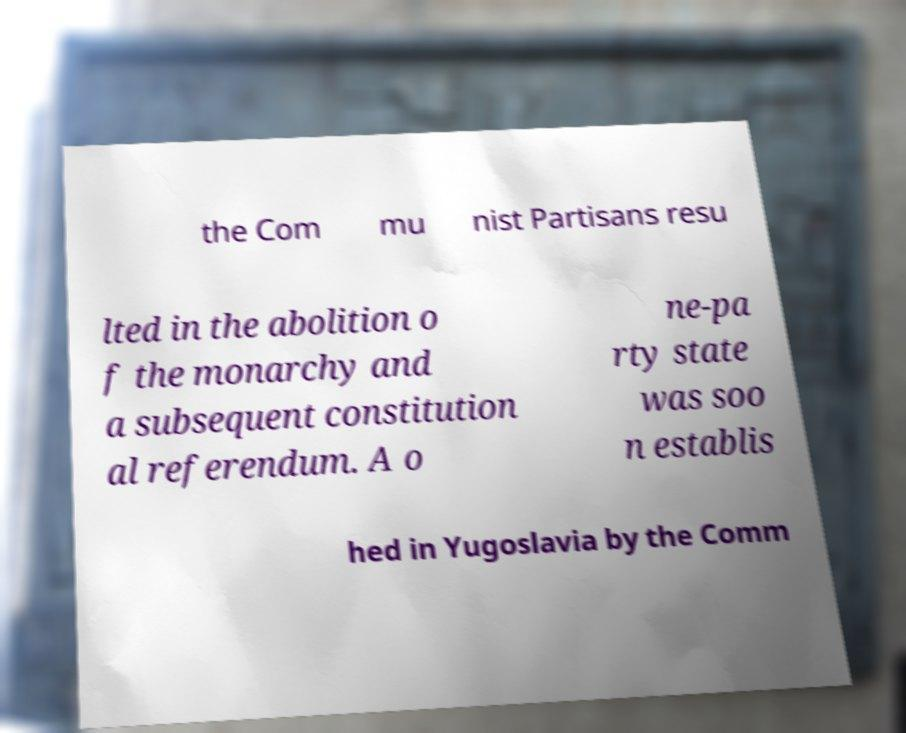I need the written content from this picture converted into text. Can you do that? the Com mu nist Partisans resu lted in the abolition o f the monarchy and a subsequent constitution al referendum. A o ne-pa rty state was soo n establis hed in Yugoslavia by the Comm 